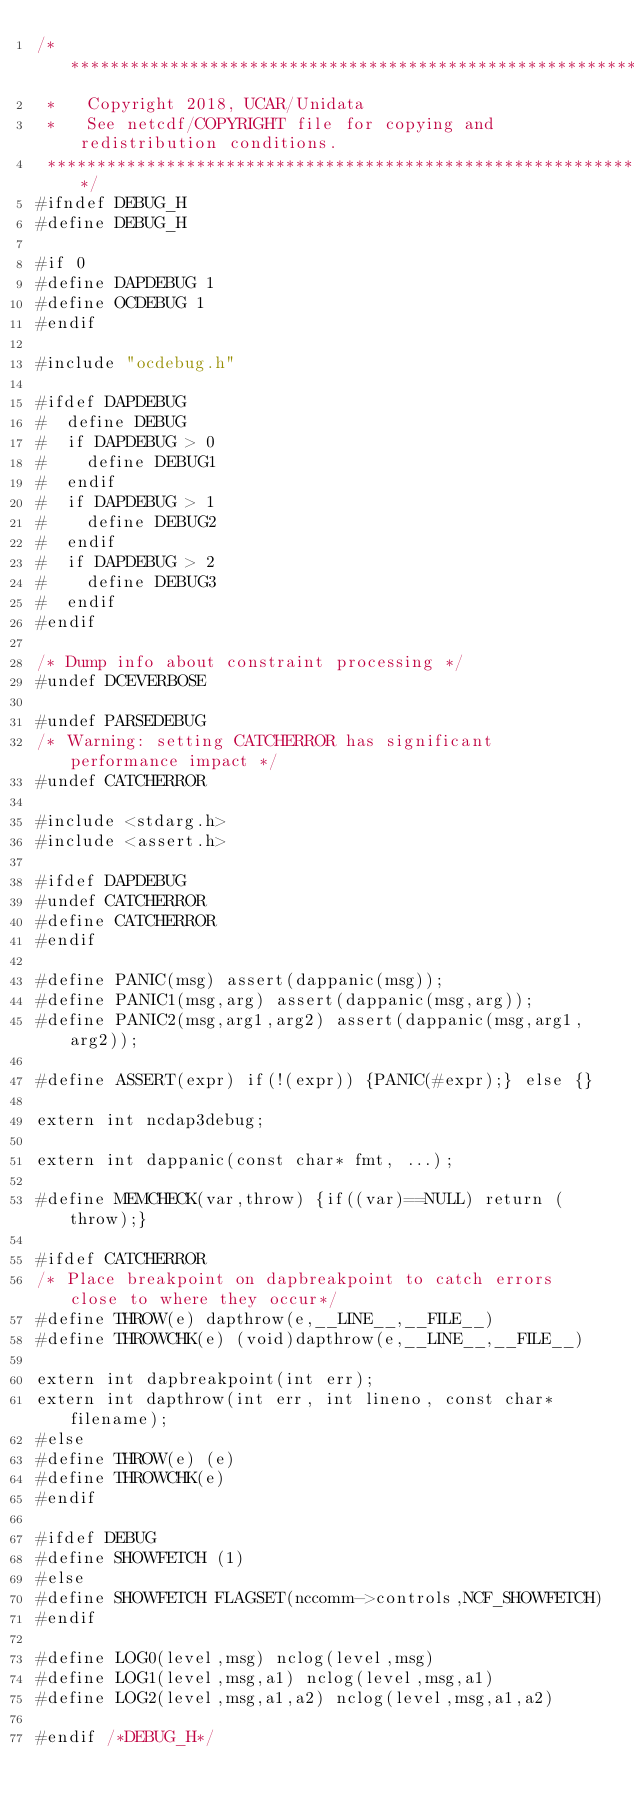Convert code to text. <code><loc_0><loc_0><loc_500><loc_500><_C_>/*********************************************************************
 *   Copyright 2018, UCAR/Unidata
 *   See netcdf/COPYRIGHT file for copying and redistribution conditions.
 *********************************************************************/
#ifndef DEBUG_H
#define DEBUG_H

#if 0
#define DAPDEBUG 1
#define OCDEBUG 1
#endif

#include "ocdebug.h"

#ifdef DAPDEBUG
#  define DEBUG
#  if DAPDEBUG > 0
#    define DEBUG1
#  endif
#  if DAPDEBUG > 1
#    define DEBUG2
#  endif
#  if DAPDEBUG > 2
#    define DEBUG3
#  endif
#endif

/* Dump info about constraint processing */
#undef DCEVERBOSE

#undef PARSEDEBUG
/* Warning: setting CATCHERROR has significant performance impact */
#undef CATCHERROR

#include <stdarg.h>
#include <assert.h>

#ifdef DAPDEBUG
#undef CATCHERROR
#define CATCHERROR
#endif

#define PANIC(msg) assert(dappanic(msg));
#define PANIC1(msg,arg) assert(dappanic(msg,arg));
#define PANIC2(msg,arg1,arg2) assert(dappanic(msg,arg1,arg2));

#define ASSERT(expr) if(!(expr)) {PANIC(#expr);} else {}

extern int ncdap3debug;

extern int dappanic(const char* fmt, ...);

#define MEMCHECK(var,throw) {if((var)==NULL) return (throw);}

#ifdef CATCHERROR
/* Place breakpoint on dapbreakpoint to catch errors close to where they occur*/
#define THROW(e) dapthrow(e,__LINE__,__FILE__)
#define THROWCHK(e) (void)dapthrow(e,__LINE__,__FILE__)

extern int dapbreakpoint(int err);
extern int dapthrow(int err, int lineno, const char* filename);
#else
#define THROW(e) (e)
#define THROWCHK(e)
#endif

#ifdef DEBUG
#define SHOWFETCH (1)
#else
#define SHOWFETCH FLAGSET(nccomm->controls,NCF_SHOWFETCH)
#endif

#define LOG0(level,msg) nclog(level,msg)
#define LOG1(level,msg,a1) nclog(level,msg,a1)
#define LOG2(level,msg,a1,a2) nclog(level,msg,a1,a2)

#endif /*DEBUG_H*/
</code> 